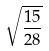Convert formula to latex. <formula><loc_0><loc_0><loc_500><loc_500>\sqrt { \frac { 1 5 } { 2 8 } }</formula> 